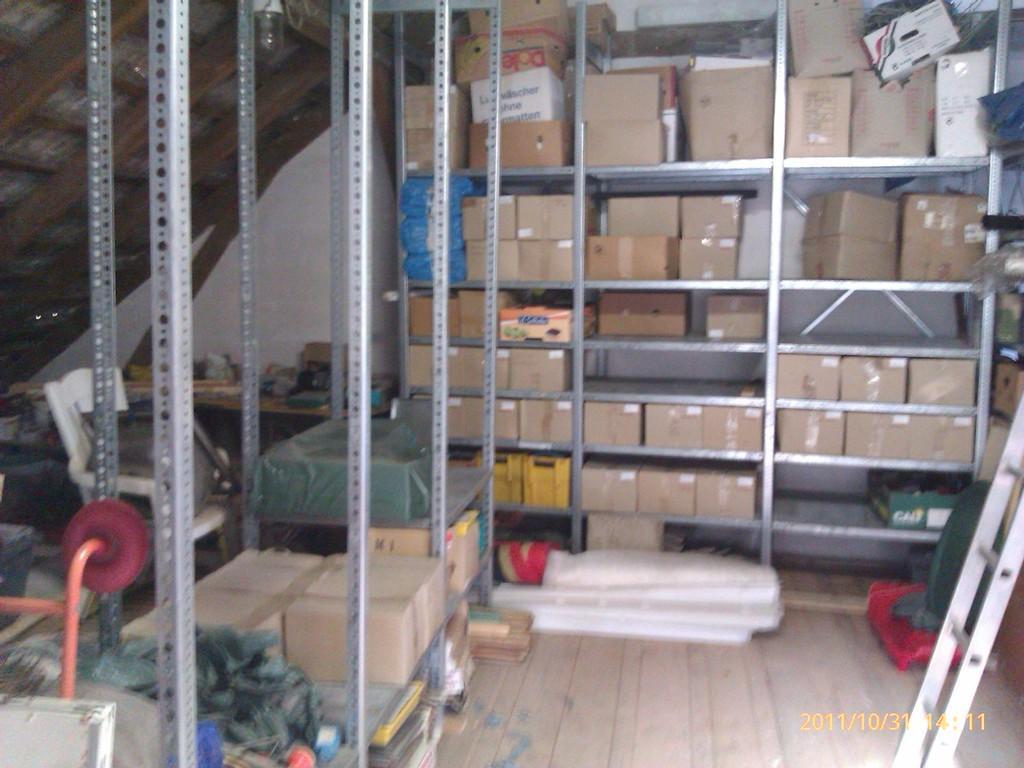Please provide a concise description of this image. In this image, we can see carton boxes and baskets are placed on the metal racks. We can see metal rods, chair, table, ladder and few objects in the image. At the bottom of the image, we can see the floor and watermark. In the background, we can see the wall, bulb and few objects. 